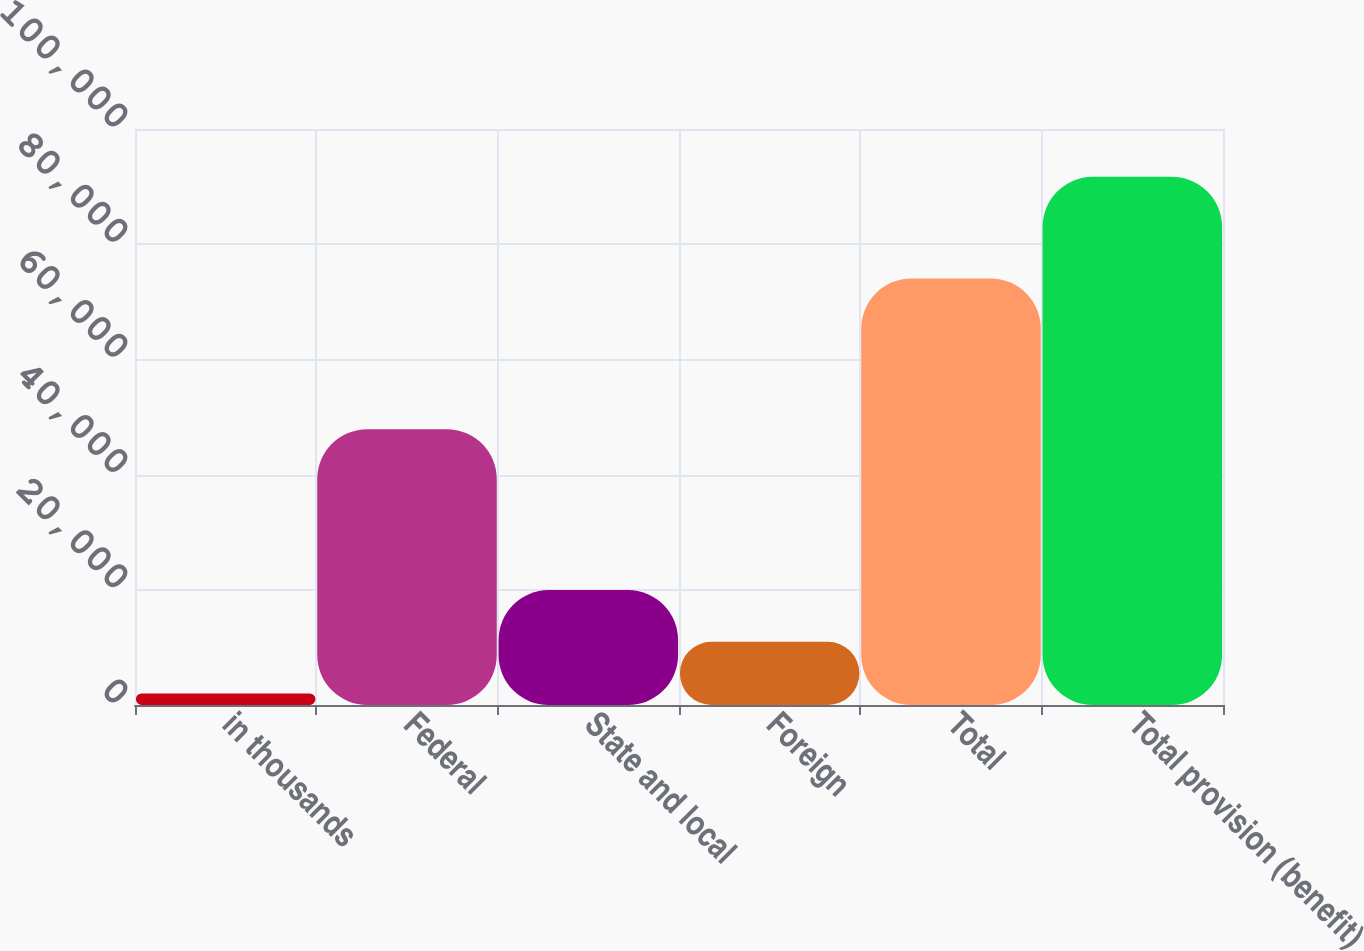Convert chart to OTSL. <chart><loc_0><loc_0><loc_500><loc_500><bar_chart><fcel>in thousands<fcel>Federal<fcel>State and local<fcel>Foreign<fcel>Total<fcel>Total provision (benefit)<nl><fcel>2014<fcel>47882<fcel>19949.6<fcel>10981.8<fcel>74039<fcel>91692<nl></chart> 